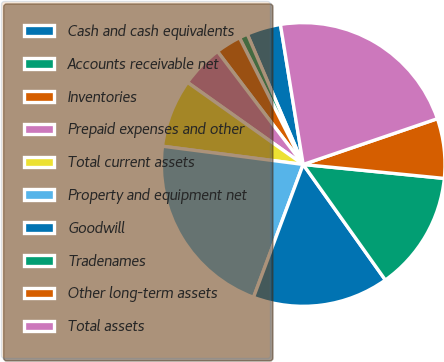<chart> <loc_0><loc_0><loc_500><loc_500><pie_chart><fcel>Cash and cash equivalents<fcel>Accounts receivable net<fcel>Inventories<fcel>Prepaid expenses and other<fcel>Total current assets<fcel>Property and equipment net<fcel>Goodwill<fcel>Tradenames<fcel>Other long-term assets<fcel>Total assets<nl><fcel>3.88%<fcel>0.97%<fcel>2.91%<fcel>4.85%<fcel>7.77%<fcel>21.36%<fcel>15.53%<fcel>13.59%<fcel>6.8%<fcel>22.33%<nl></chart> 